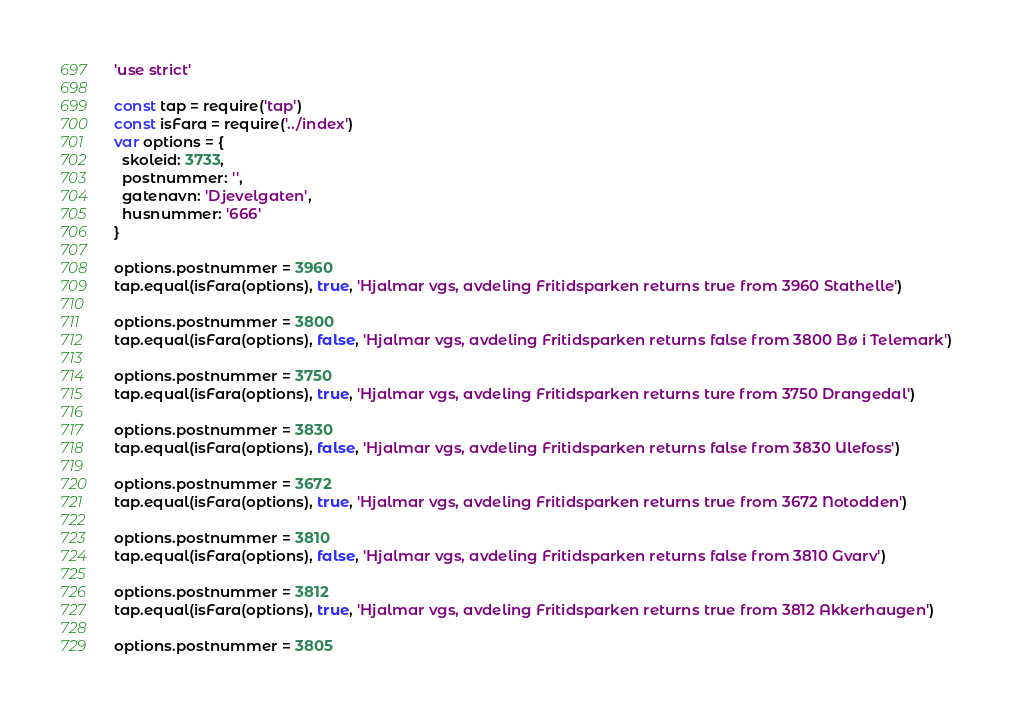<code> <loc_0><loc_0><loc_500><loc_500><_JavaScript_>'use strict'

const tap = require('tap')
const isFara = require('../index')
var options = {
  skoleid: 3733,
  postnummer: '',
  gatenavn: 'Djevelgaten',
  husnummer: '666'
}

options.postnummer = 3960
tap.equal(isFara(options), true, 'Hjalmar vgs, avdeling Fritidsparken returns true from 3960 Stathelle')

options.postnummer = 3800
tap.equal(isFara(options), false, 'Hjalmar vgs, avdeling Fritidsparken returns false from 3800 Bø i Telemark')

options.postnummer = 3750
tap.equal(isFara(options), true, 'Hjalmar vgs, avdeling Fritidsparken returns ture from 3750 Drangedal')

options.postnummer = 3830
tap.equal(isFara(options), false, 'Hjalmar vgs, avdeling Fritidsparken returns false from 3830 Ulefoss')

options.postnummer = 3672
tap.equal(isFara(options), true, 'Hjalmar vgs, avdeling Fritidsparken returns true from 3672 Notodden')

options.postnummer = 3810
tap.equal(isFara(options), false, 'Hjalmar vgs, avdeling Fritidsparken returns false from 3810 Gvarv')

options.postnummer = 3812
tap.equal(isFara(options), true, 'Hjalmar vgs, avdeling Fritidsparken returns true from 3812 Akkerhaugen')

options.postnummer = 3805</code> 